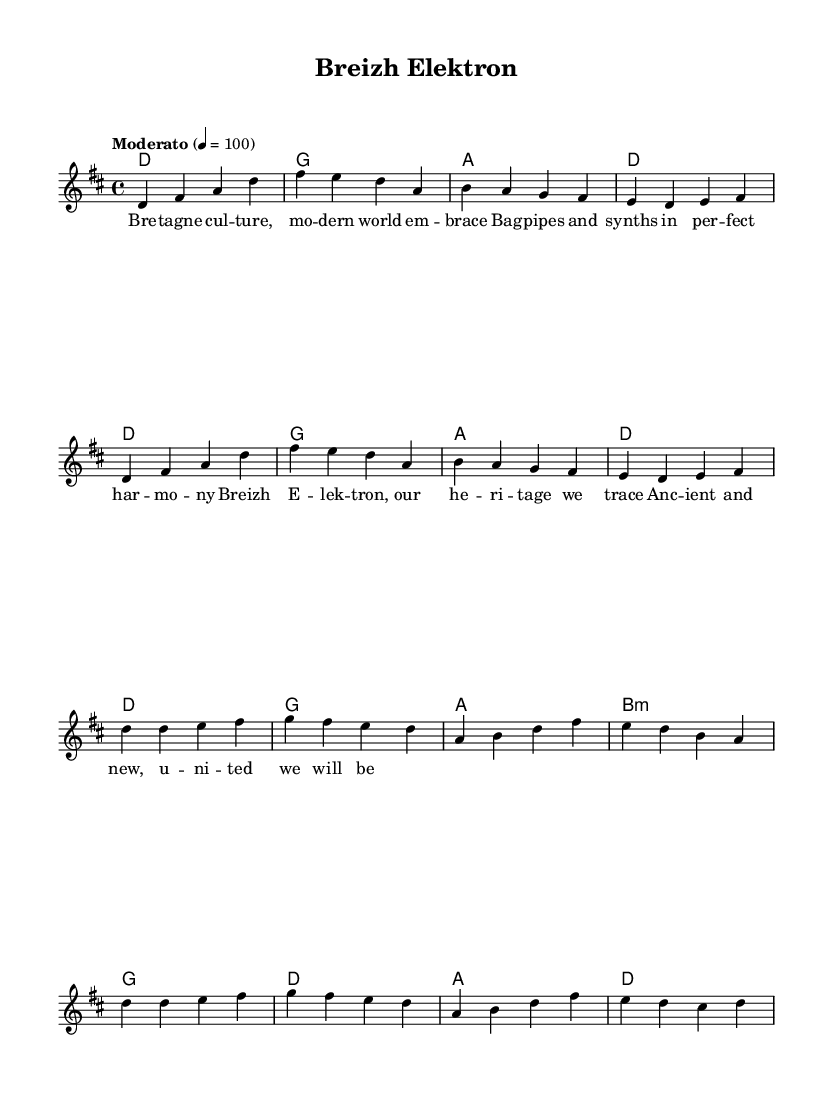What is the key signature of this music? The key signature is determined by the sharps or flats present at the beginning of the staff. In this case, it indicates D major, which has two sharps.
Answer: D major What is the time signature of this music? The time signature can be found at the beginning of the staff and signifies how many beats are in each measure. Here, it shows 4/4, meaning there are four beats per measure.
Answer: 4/4 What is the tempo marking for the music? The tempo marking is indicated in the score, providing the speed of the piece. It shows "Moderato" with a metronomic marking of 100 beats per minute.
Answer: Moderato, 100 What are the first four notes of the melody? By examining the melody section at the beginning, the first four notes are D, F sharp, A, and D.
Answer: D, F sharp, A, D How many measures are in the chorus section? To determine the number of measures, one must count the measures contained within the chorus from the score. The chorus has eight measures based on the higher level structure of the music.
Answer: 8 What instruments are likely included in this arrangement based on the title? The title mentions "Breizh Elektron," suggesting the inclusion of traditional Breton bagpipes and electronic components. Therefore, these are likely the instruments used.
Answer: Bagpipes and electronics What cultural significance does the title "Breizh Elektron" suggest for this piece? The title directly references "Breizh," the Breton word for Brittany, indicating the piece likely incorporates elements of Breton culture fused with modern music, highlighting the importance of heritage.
Answer: Breton heritage fusion 